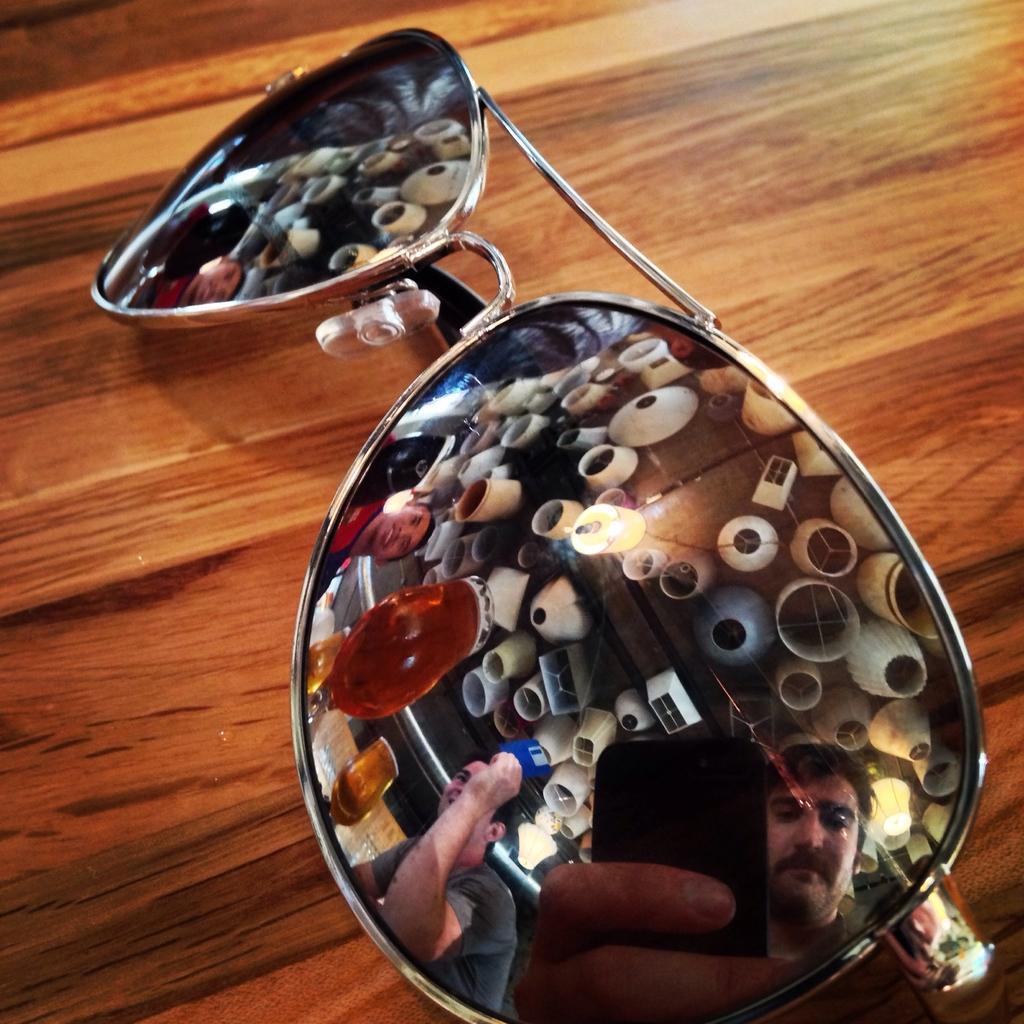Describe this image in one or two sentences. This picture is consists of the image of the sun glasses, which is placed on the wooden table, and the faces of the people those who are standing to the other side of the image are appearing in the glasses. 